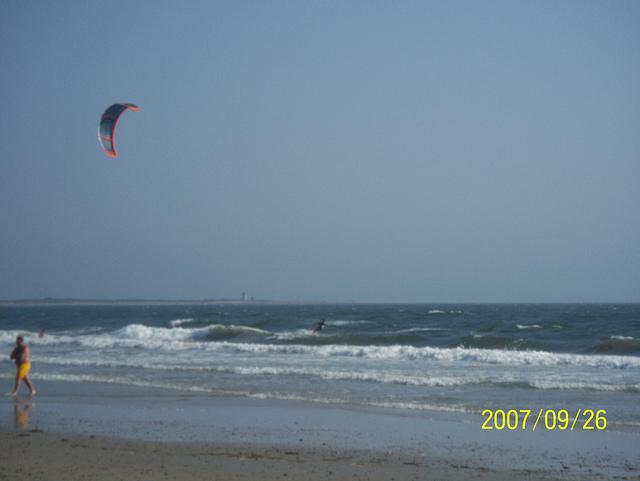What is the man holding?
Give a very brief answer. Kite. What color trunks is the man that is walking out of the water wearing?
Quick response, please. Yellow. When was this picture taken?
Concise answer only. 2007/09/26. Are the waves small?
Answer briefly. Yes. 